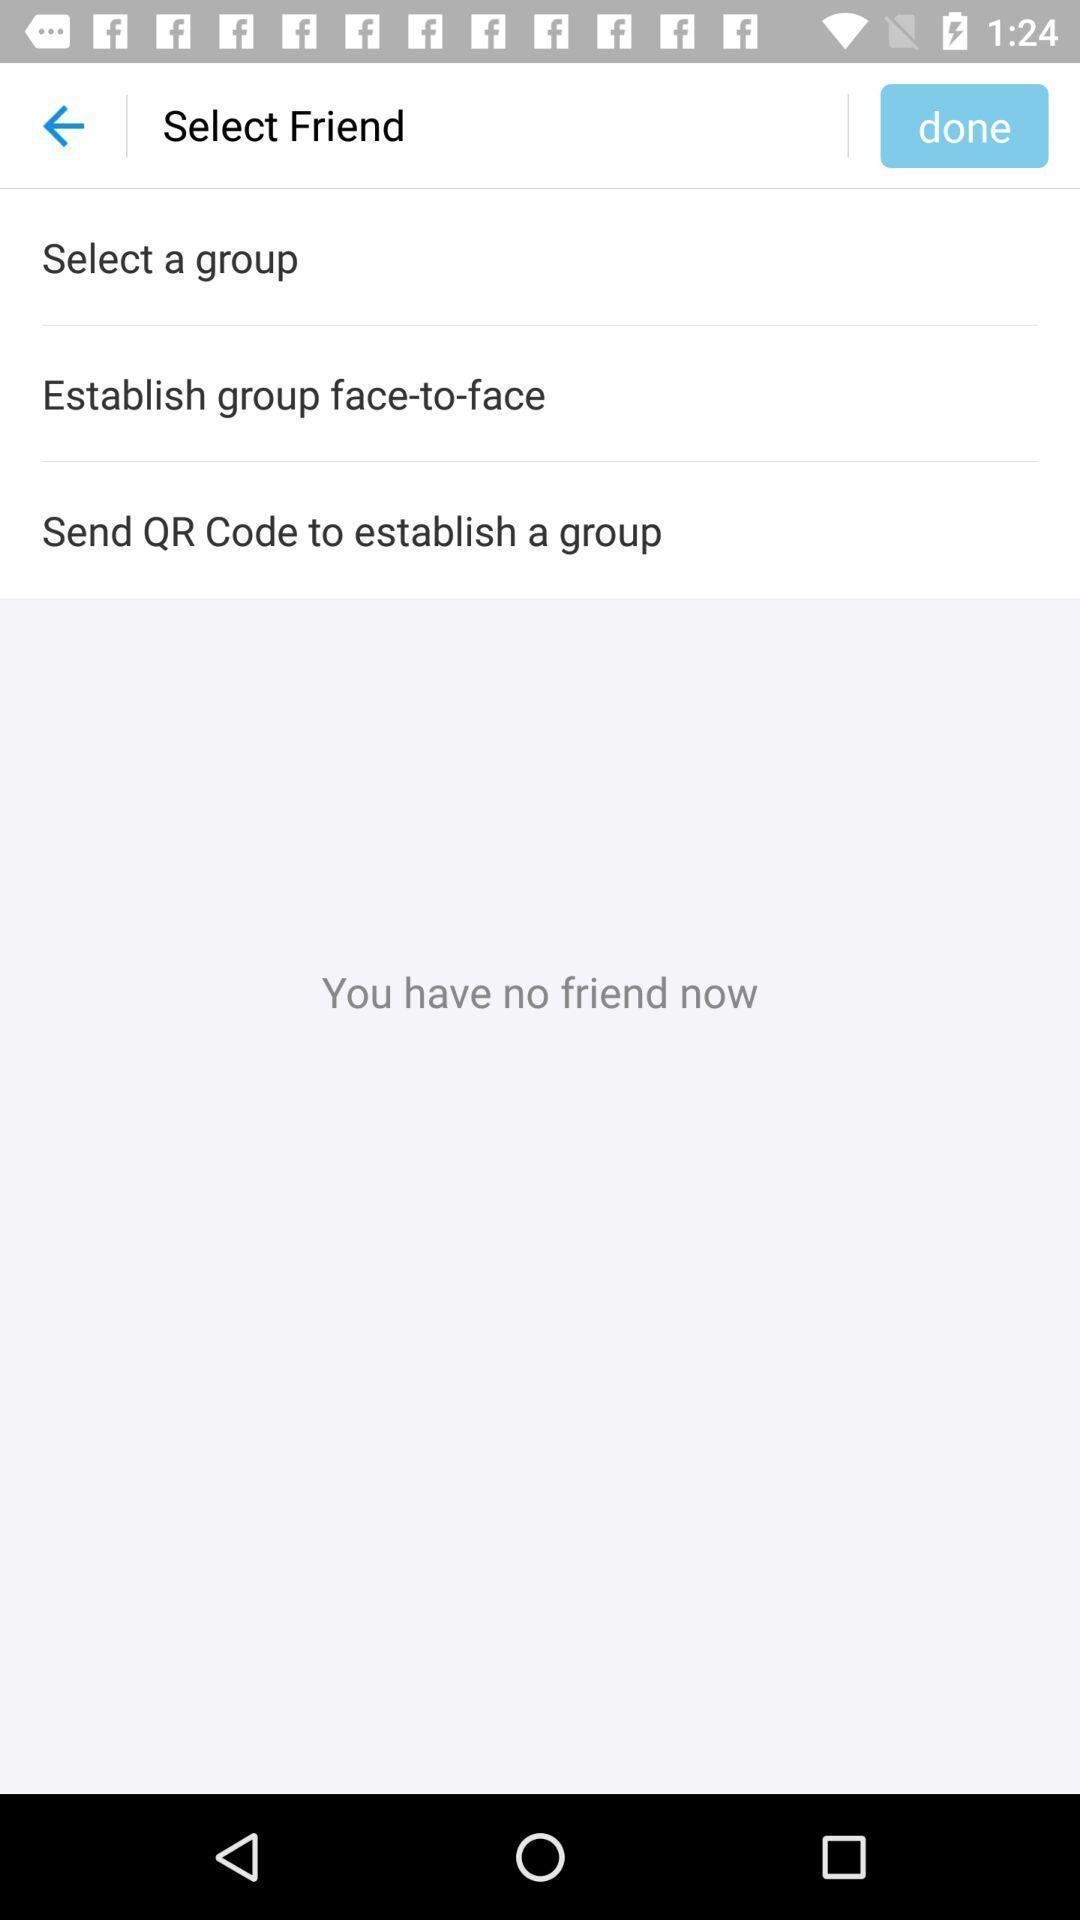Please provide a description for this image. Screen displaying multiple group options. 